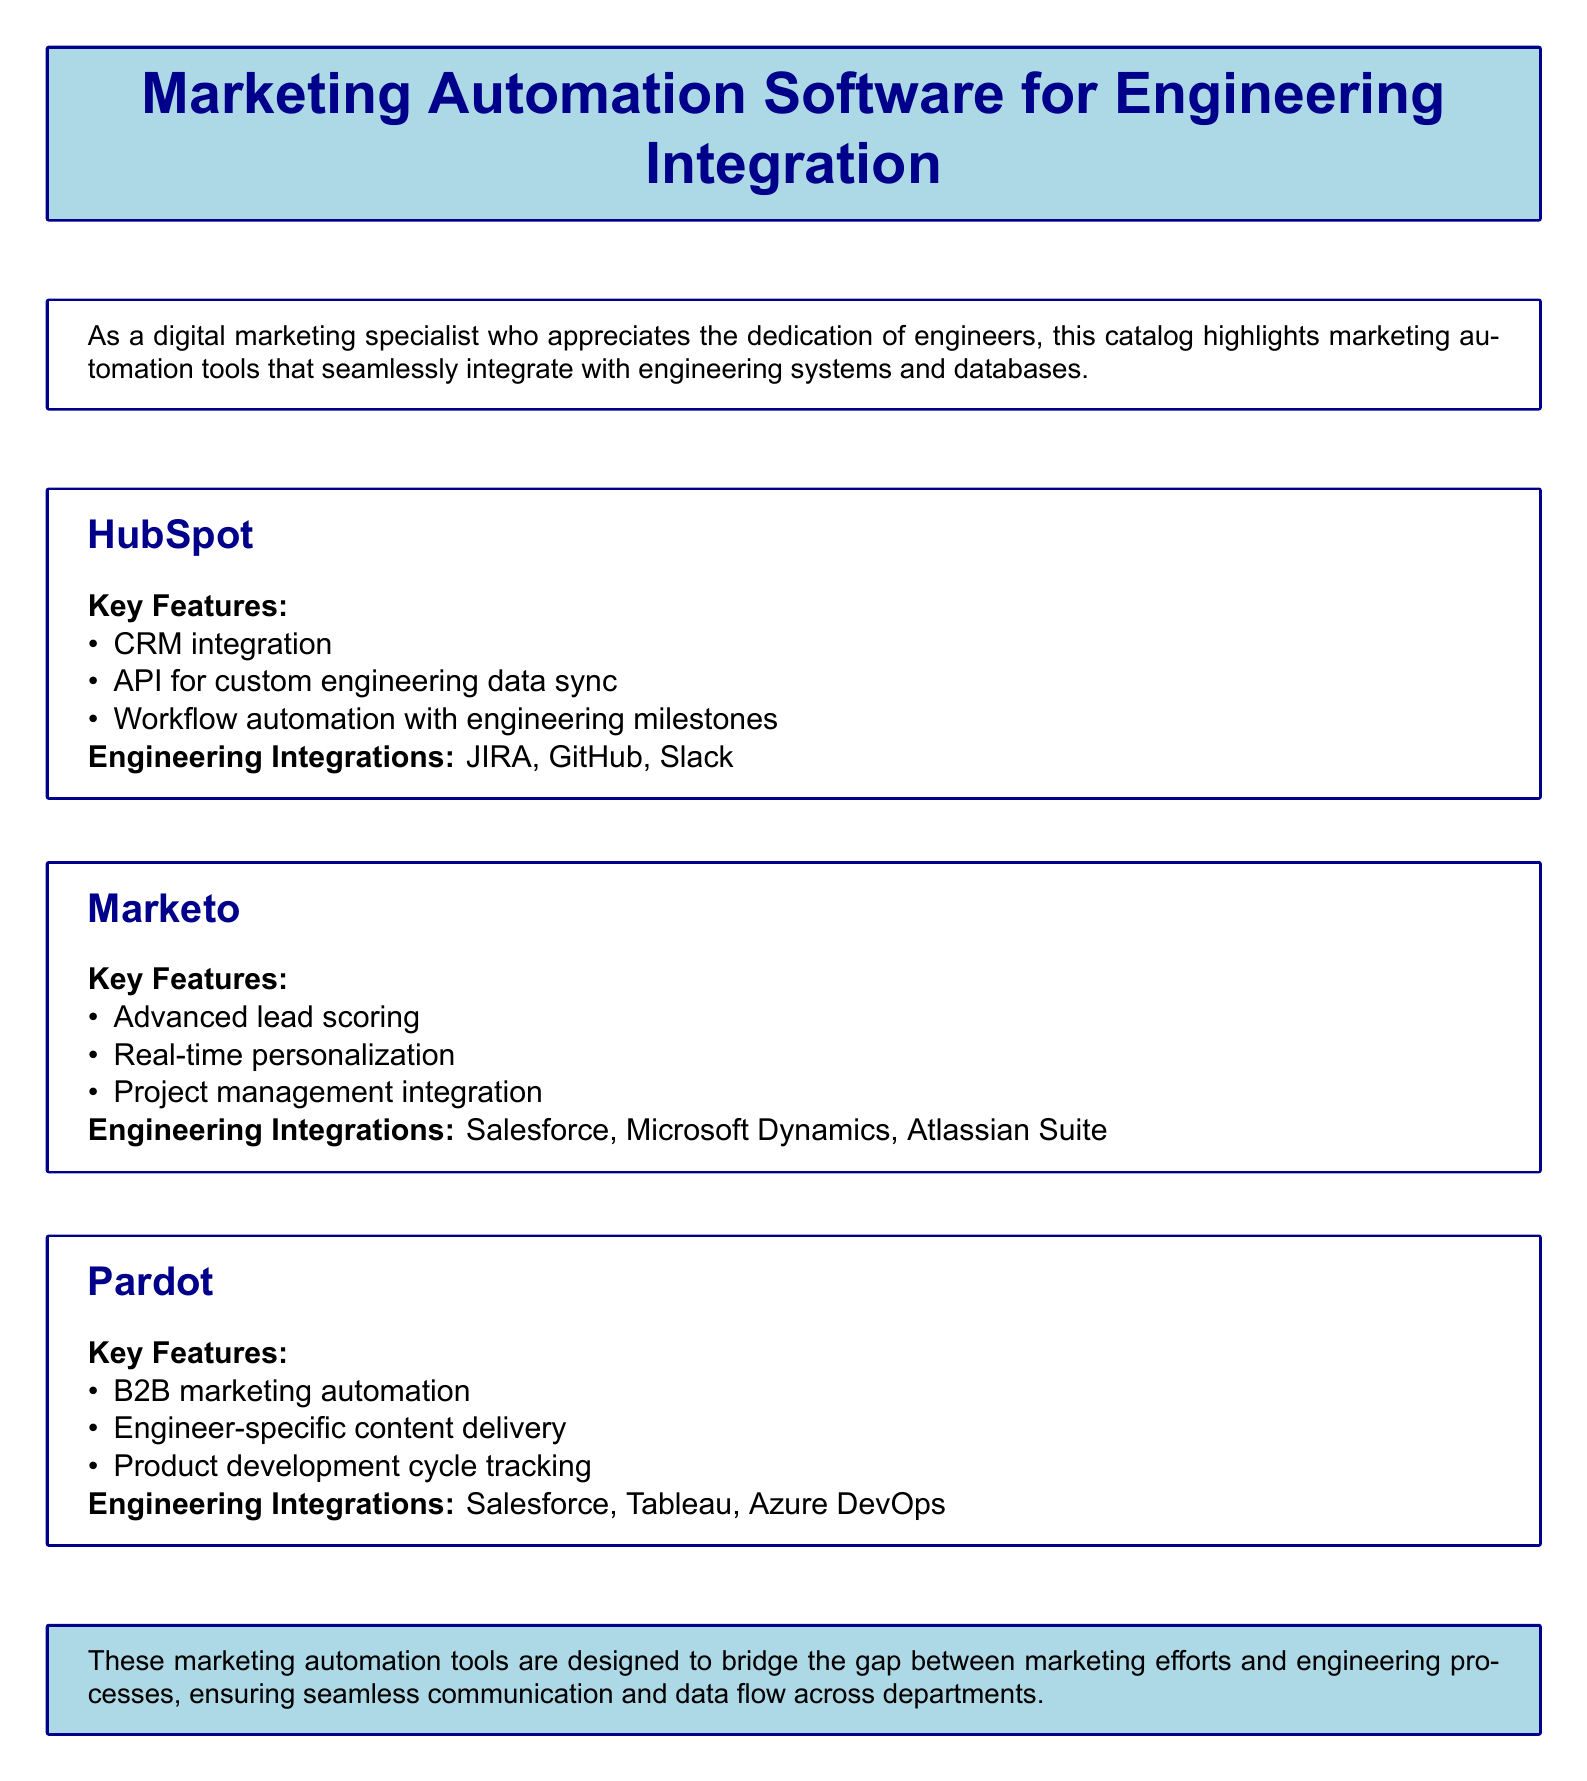What is the title of the catalog? The title of the catalog is prominently displayed at the top of the document.
Answer: Marketing Automation Software for Engineering Integration What is the document's primary focus? The document provides insights into marketing automation tools and their integration with engineering systems.
Answer: Seamless integration with engineering systems Which software is listed first in the catalog? The catalog lists software in a specific order.
Answer: HubSpot What are the key features of Pardot? The key features are enumerated for each software, specifically for Pardot.
Answer: B2B marketing automation, Engineer-specific content delivery, Product development cycle tracking Which engineering integrations does Marketo support? The integrations for Marketo are explicitly listed in the document.
Answer: Salesforce, Microsoft Dynamics, Atlassian Suite How many key features does HubSpot have? The number of key features can be counted based on the bullet points provided.
Answer: Three What is the color scheme used for the title box? The color scheme is described in terms of the background and frame colors of the title box.
Answer: Light blue background, dark blue frame What type of marketing automation does Pardot specialize in? The specialization of Pardot is mentioned in the key features section.
Answer: B2B marketing automation What does the document suggest about the relationship between marketing and engineering? The final box summarizes the document's perspective on marketing and engineering collaboration.
Answer: Bridges the gap between marketing efforts and engineering processes 